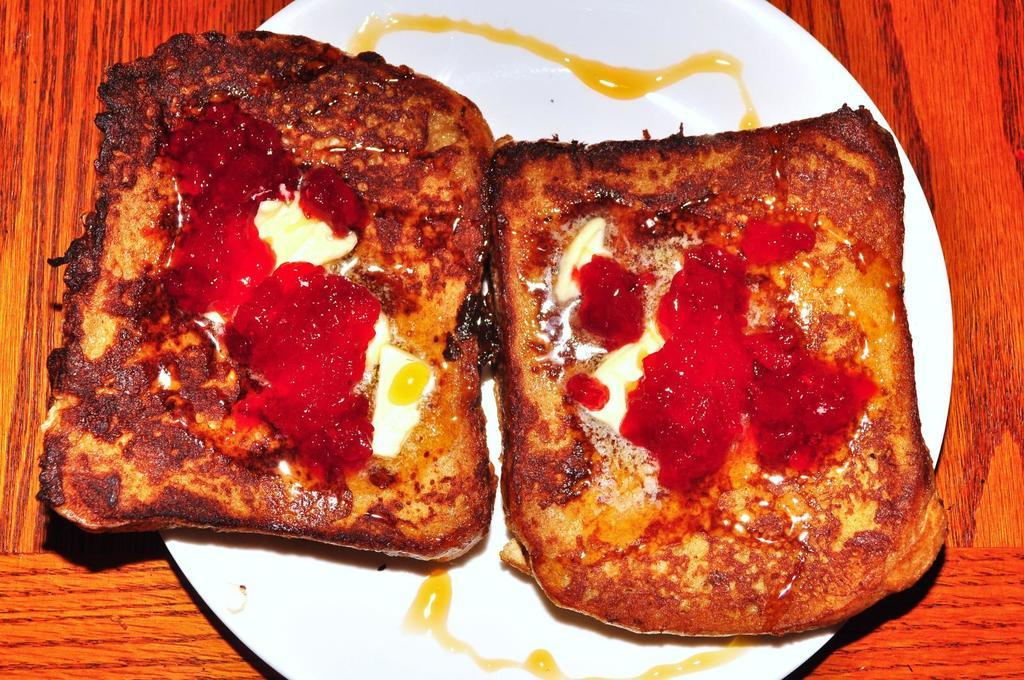What is on the plate that is visible in the image? There is food on a white plate in the image. What can be seen beneath the plate in the image? The plate is on a red and brown color surface. What colors are present in the food on the plate? The food has colors including red, white, brown, and black. How many dogs are playing an instrument in the image? There are no dogs or instruments present in the image. 